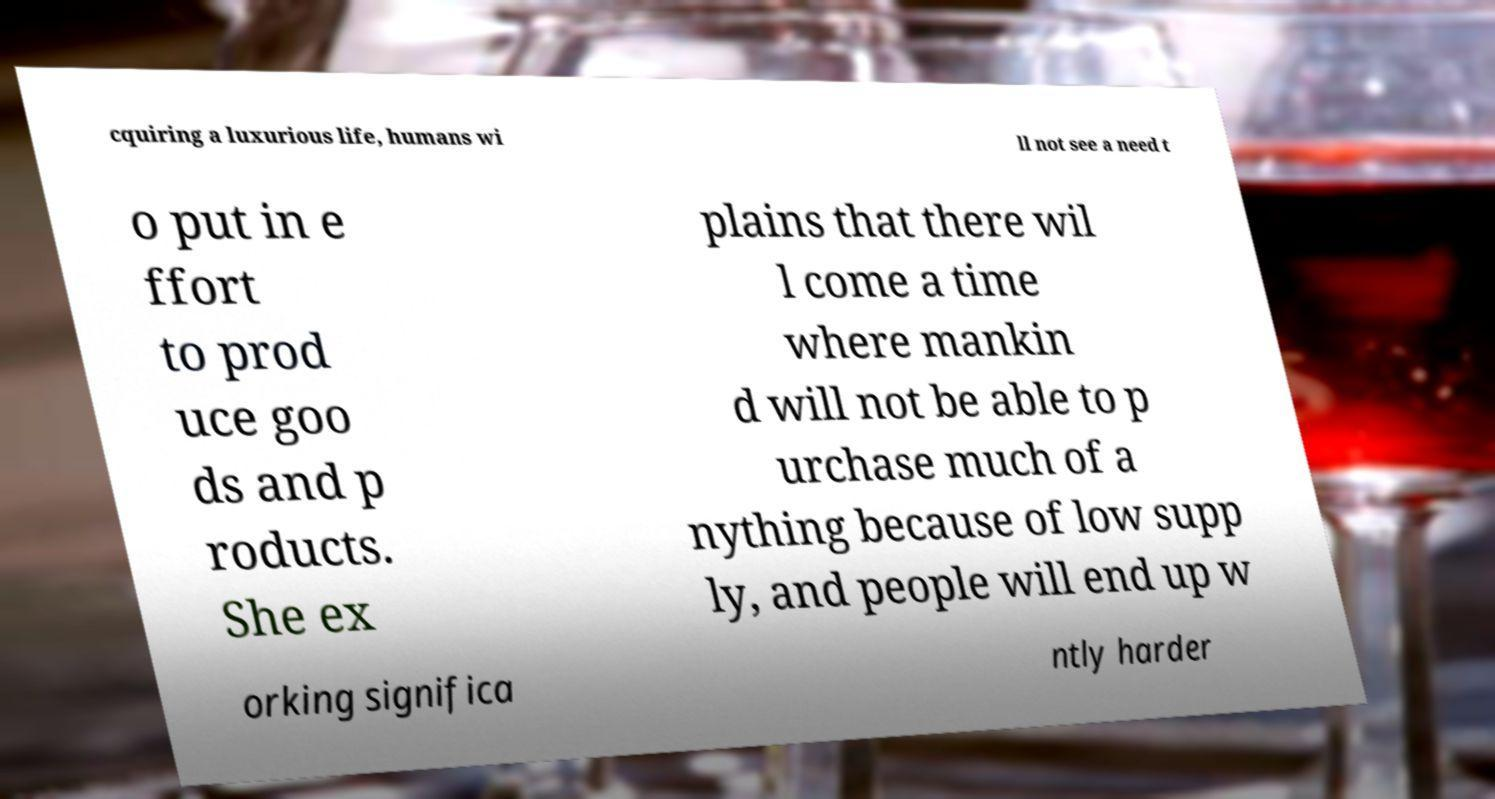I need the written content from this picture converted into text. Can you do that? cquiring a luxurious life, humans wi ll not see a need t o put in e ffort to prod uce goo ds and p roducts. She ex plains that there wil l come a time where mankin d will not be able to p urchase much of a nything because of low supp ly, and people will end up w orking significa ntly harder 